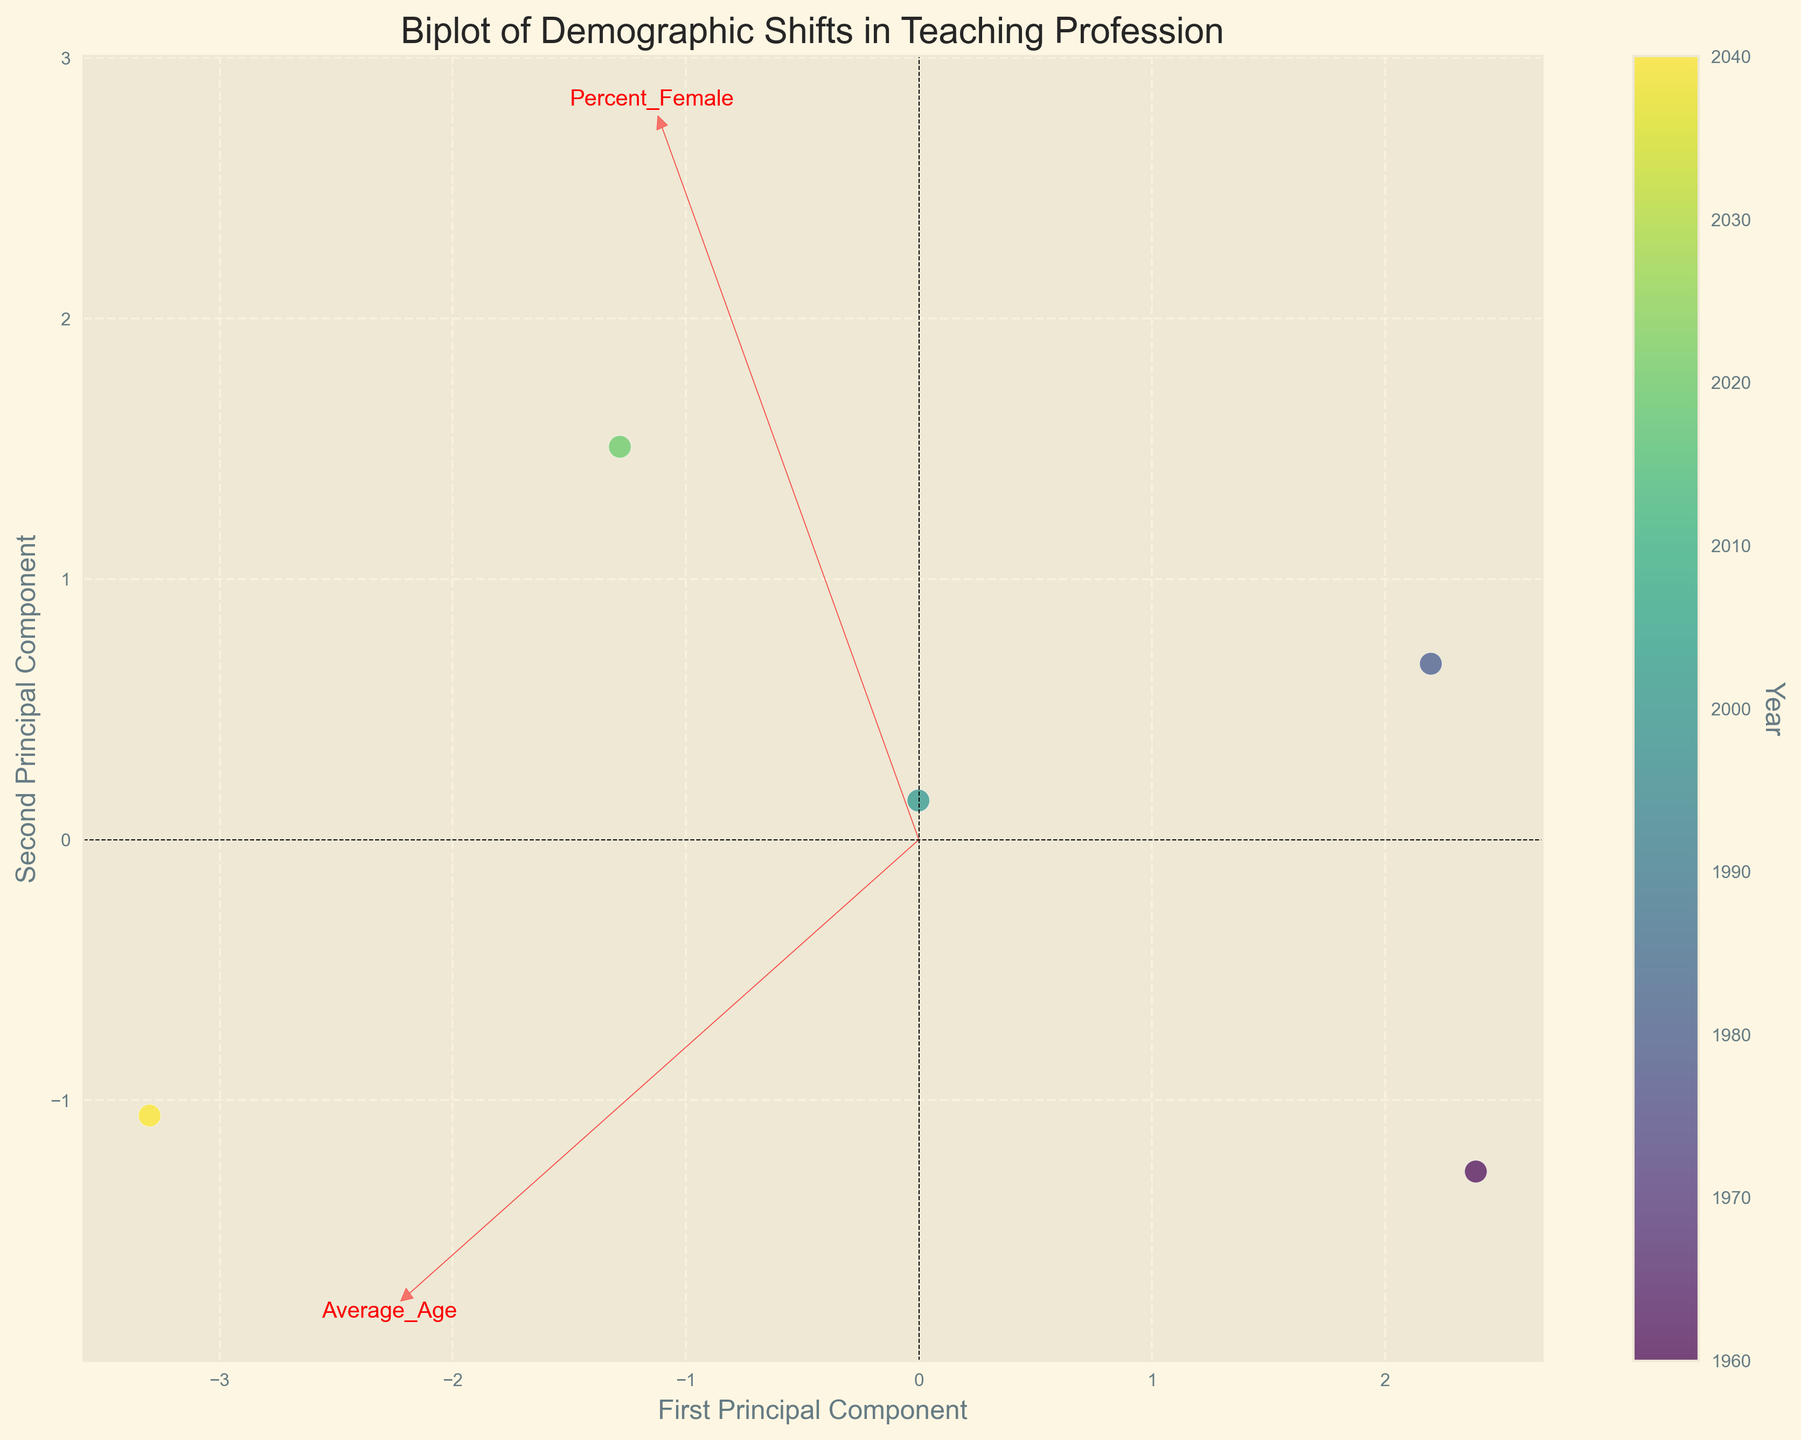How many years are represented in the figure? The figure includes data points for each represented year, shown by different colors on the plot. Count the number of unique colors to determine the number of represented years.
Answer: 5 What is the title of the plot? The title is displayed at the top of the plot, providing a high-level description of the visualized data.
Answer: Biplot of Demographic Shifts in Teaching Profession Which principal component has values on the horizontal axis? The labels on the horizontal axis indicate the explanatory variable plotted, here marked as the "First Principal Component."
Answer: First Principal Component What feature vector points in the most positive direction on the first principal component axis? Observe the arrows corresponding to feature vectors; the one extended the furthest right on the first principal component axis represents the dominant feature.
Answer: Percent Hispanic How does the average age of teachers change from 1960 to 2040? Compare the positions of the data points along the principal component axes, colored by year, and track changes in the "Average_Age" feature vector from early to later years.
Answer: Increases What is the relationship between Percent White and Percent Hispanic over the years? Examine where the arrows representing "Percent White" and "Percent Hispanic" point. Determining the relationship involves noting these vectors' influence on the placement of data points over different years.
Answer: Inversely related Which demographic feature shows the least change over the years? Observe the length and direction of the arrows; the smaller the vector and the less it deviates, the smaller the corresponding change over the years.
Answer: Percent Black Compare the average age between 1980 and 2000. Identify the points representing 1980 and 2000 and compare their positions relative to the "Average_Age" vector.
Answer: Slight increase What does a positive value in the second principal component represent? Look at the feature vectors and see which demographic shifts contribute positively in the direction of the second principal component axis.
Answer: Higher Percent Hispanic and Percent Asian Which year has the most diverse racial representation according to the plot? Diversity can be inferred by the way data points spread out along racial demographic feature vectors over the years. Locate the year data point spread furthest along these axes.
Answer: 2040 